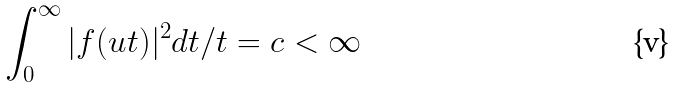Convert formula to latex. <formula><loc_0><loc_0><loc_500><loc_500>\int _ { 0 } ^ { \infty } | f ( u t ) | ^ { 2 } d t / t = c < \infty</formula> 